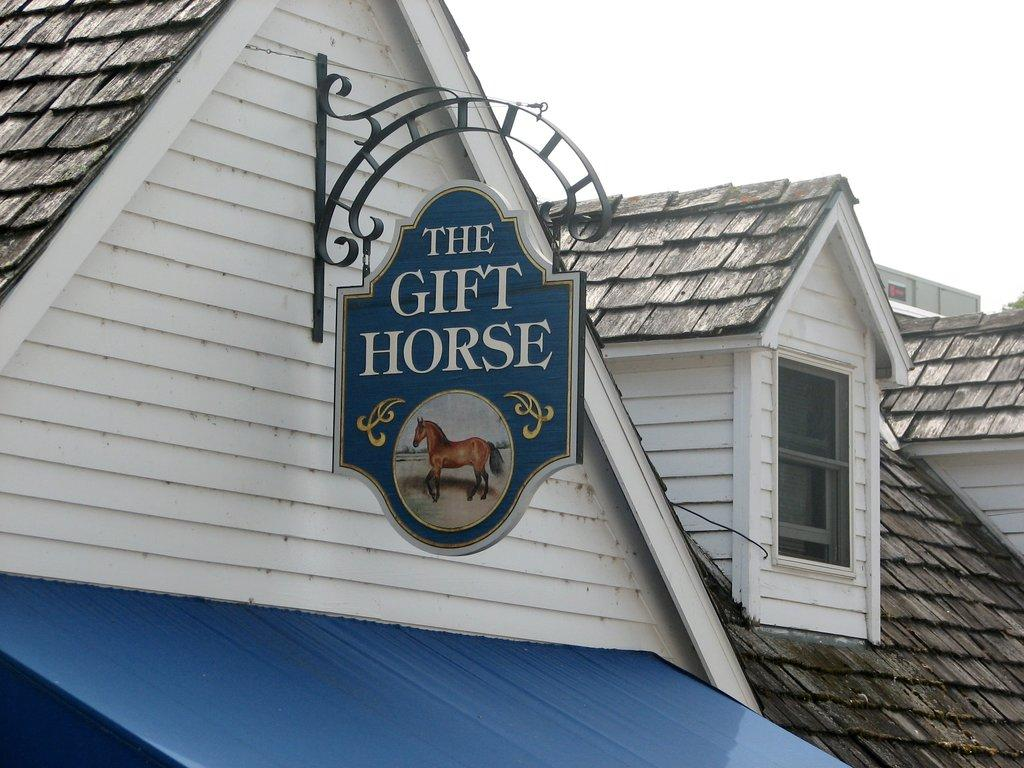What is the setting of the image? The image shows the rooftop of a house. What object can be seen on the rooftop? There is a board on the rooftop. What is depicted on the board? The board has a picture of a horse. What is visible at the top of the image? The sky is visible at the top of the image. What type of dinner is being served on the rooftop in the image? There is no dinner being served in the image; it shows a board with a picture of a horse on the rooftop. Who owns the property in the image? The image does not provide information about the ownership of the property. 